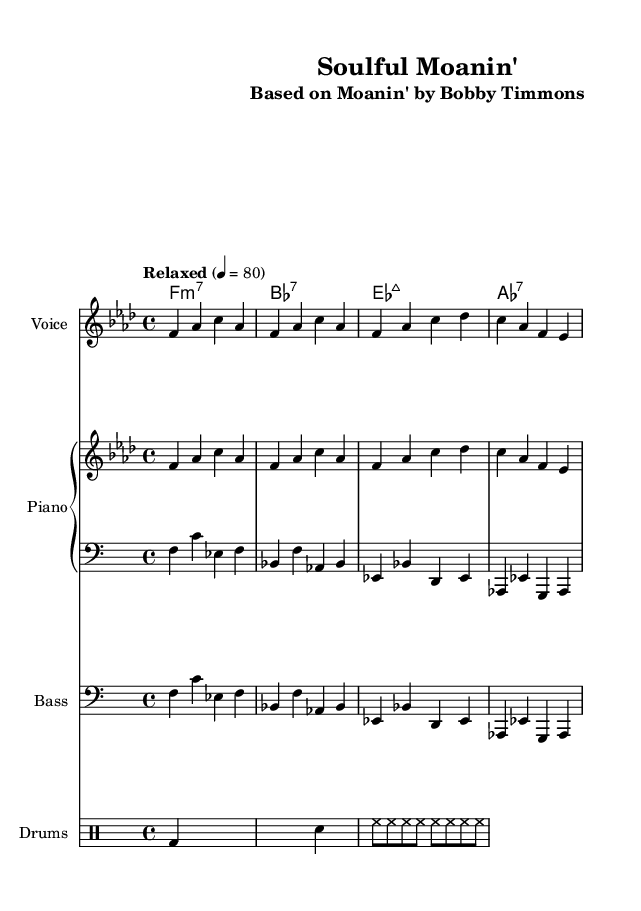What is the key signature of this music? The key signature is indicated by the number of flats or sharps at the beginning of the staff. In this case, the key of F minor has four flats (B♭, E♭, A♭, D♭), which is shown on the staff.
Answer: F minor What is the time signature of this piece? The time signature is found at the beginning of the staff, indicating how many beats are in each measure. Here, the time signature is 4/4, meaning there are four beats per measure, and the quarter note gets one beat.
Answer: 4/4 What is the tempo marking for the piece? The tempo marking is written above the staff and indicates the pace of the music. The specified tempo is "Relaxed" at 4 = 80, which means to play at a relaxed speed of 80 beats per minute.
Answer: Relaxed What is the predominant chord at the beginning of the harmony section? The harmony section starts with a chord symbol that indicates the first chord played, which in this case is F minor 7 (f1:m7). This chord determines the tonal center of the piece.
Answer: F:m7 In which style is this arrangement primarily composed? The arrangement is based on classic jazz standards, but it leans into a soulful interpretation, which is a hallmark of "soul" music. This influence can be seen in the phrasing and emotional delivery typical of the soul genre.
Answer: Soulful How many total staves are included in this score? By counting each separate staff that is indicated for different instrumentalists, we see that there are four distinct staves: Voice, Piano (two separate staves for melody and bass), and Bass, as well as a Drum staff.
Answer: Four 